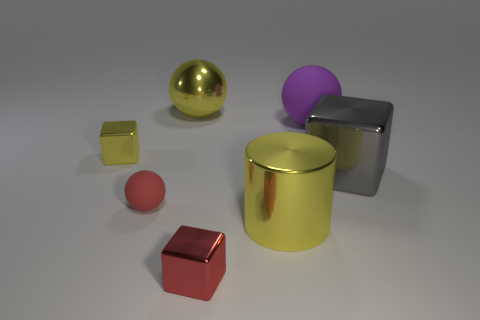Subtract all gray cubes. How many cubes are left? 2 Add 3 green matte cylinders. How many objects exist? 10 Subtract 2 cubes. How many cubes are left? 1 Subtract all cubes. How many objects are left? 4 Subtract all yellow cylinders. How many purple spheres are left? 1 Subtract all purple metal cylinders. Subtract all large gray metal blocks. How many objects are left? 6 Add 2 large metal blocks. How many large metal blocks are left? 3 Add 7 yellow cylinders. How many yellow cylinders exist? 8 Subtract 0 cyan cubes. How many objects are left? 7 Subtract all green blocks. Subtract all blue cylinders. How many blocks are left? 3 